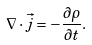<formula> <loc_0><loc_0><loc_500><loc_500>\nabla \cdot \vec { j } = - \frac { \partial \rho } { \partial t } .</formula> 